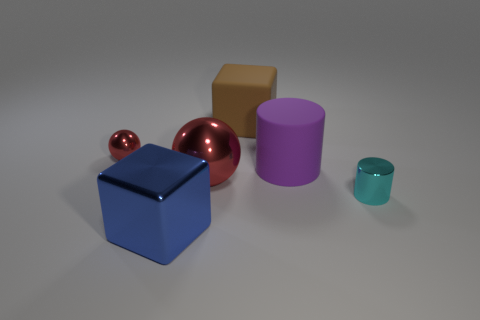Add 4 cyan metal cylinders. How many objects exist? 10 Subtract all cubes. How many objects are left? 4 Add 1 large yellow matte cylinders. How many large yellow matte cylinders exist? 1 Subtract 0 gray cylinders. How many objects are left? 6 Subtract all big red cubes. Subtract all small spheres. How many objects are left? 5 Add 1 big objects. How many big objects are left? 5 